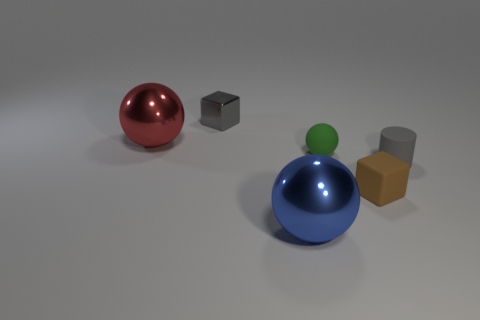Subtract all cyan cylinders. Subtract all brown spheres. How many cylinders are left? 1 Add 2 tiny cyan cylinders. How many objects exist? 8 Subtract all cylinders. How many objects are left? 5 Subtract 0 red blocks. How many objects are left? 6 Subtract all large red objects. Subtract all large blue shiny spheres. How many objects are left? 4 Add 2 balls. How many balls are left? 5 Add 4 small yellow cylinders. How many small yellow cylinders exist? 4 